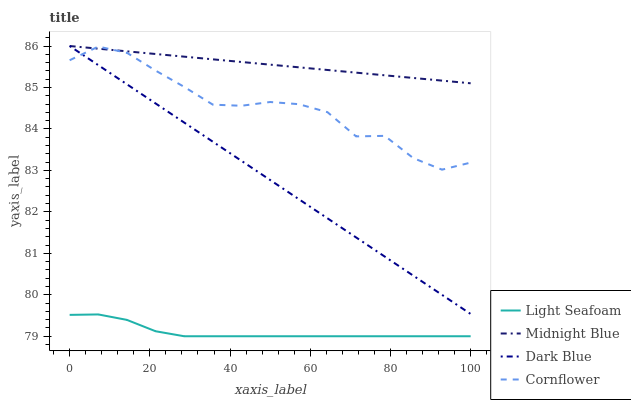Does Light Seafoam have the minimum area under the curve?
Answer yes or no. Yes. Does Midnight Blue have the maximum area under the curve?
Answer yes or no. Yes. Does Midnight Blue have the minimum area under the curve?
Answer yes or no. No. Does Light Seafoam have the maximum area under the curve?
Answer yes or no. No. Is Dark Blue the smoothest?
Answer yes or no. Yes. Is Cornflower the roughest?
Answer yes or no. Yes. Is Light Seafoam the smoothest?
Answer yes or no. No. Is Light Seafoam the roughest?
Answer yes or no. No. Does Light Seafoam have the lowest value?
Answer yes or no. Yes. Does Midnight Blue have the lowest value?
Answer yes or no. No. Does Midnight Blue have the highest value?
Answer yes or no. Yes. Does Light Seafoam have the highest value?
Answer yes or no. No. Is Light Seafoam less than Cornflower?
Answer yes or no. Yes. Is Dark Blue greater than Light Seafoam?
Answer yes or no. Yes. Does Dark Blue intersect Midnight Blue?
Answer yes or no. Yes. Is Dark Blue less than Midnight Blue?
Answer yes or no. No. Is Dark Blue greater than Midnight Blue?
Answer yes or no. No. Does Light Seafoam intersect Cornflower?
Answer yes or no. No. 